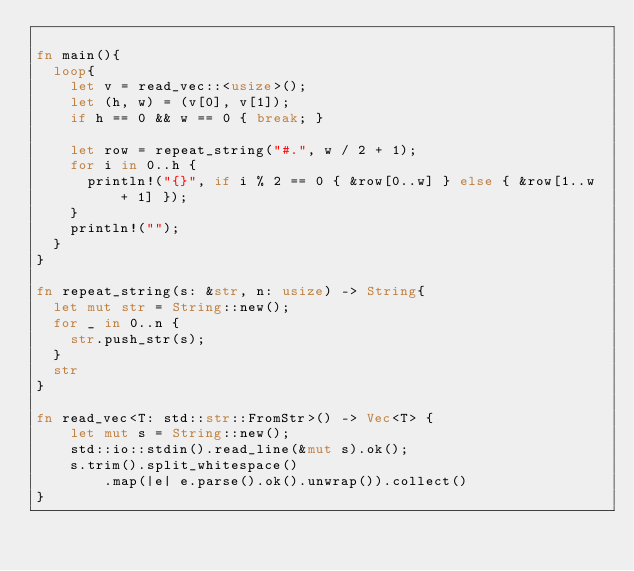<code> <loc_0><loc_0><loc_500><loc_500><_Rust_>
fn main(){
	loop{
		let v = read_vec::<usize>();
		let (h, w) = (v[0], v[1]);
		if h == 0 && w == 0 { break; }
		
		let row = repeat_string("#.", w / 2 + 1);
		for i in 0..h {
			println!("{}", if i % 2 == 0 { &row[0..w] } else { &row[1..w + 1] });
		}
		println!("");
	}
}

fn repeat_string(s: &str, n: usize) -> String{
	let mut str = String::new();
	for _ in 0..n {
		str.push_str(s);
	}
	str
}

fn read_vec<T: std::str::FromStr>() -> Vec<T> {
    let mut s = String::new();
    std::io::stdin().read_line(&mut s).ok();
    s.trim().split_whitespace()
        .map(|e| e.parse().ok().unwrap()).collect()
}
</code> 